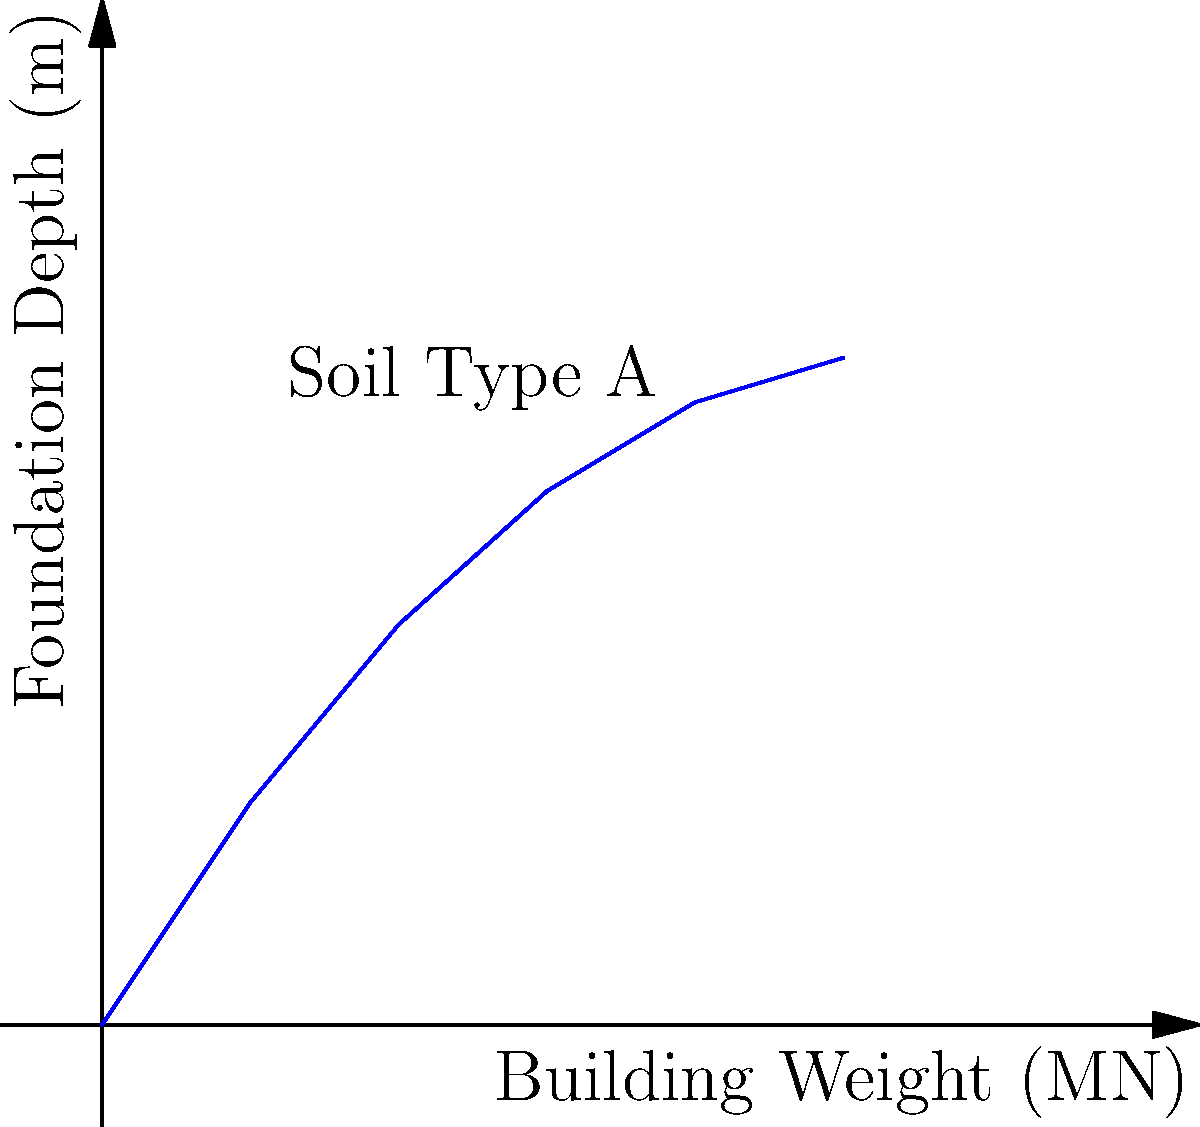A video production studio is planning to construct a new facility. The graph shows the relationship between building weight and required foundation depth for a specific soil type. If the proposed studio building weighs 3.5 MN, what is the approximate required foundation depth to ensure stability? To determine the required foundation depth for the video production studio, we'll follow these steps:

1. Identify the given information:
   - Building weight: 3.5 MN
   - Graph showing the relationship between building weight and foundation depth

2. Locate the building weight on the x-axis:
   - Find 3.5 MN on the "Building Weight" axis

3. Draw a vertical line from the 3.5 MN point until it intersects the curve

4. From the intersection point, draw a horizontal line to the y-axis

5. Read the value on the y-axis where the horizontal line intersects:
   - This value represents the required foundation depth

6. Estimate the depth based on the graph:
   - The intersection point appears to be between 3.6 m and 4.2 m
   - Interpolating between these values, we can estimate the depth to be approximately 3.9 m

Therefore, the approximate required foundation depth for the 3.5 MN video production studio building is 3.9 meters.
Answer: 3.9 m 